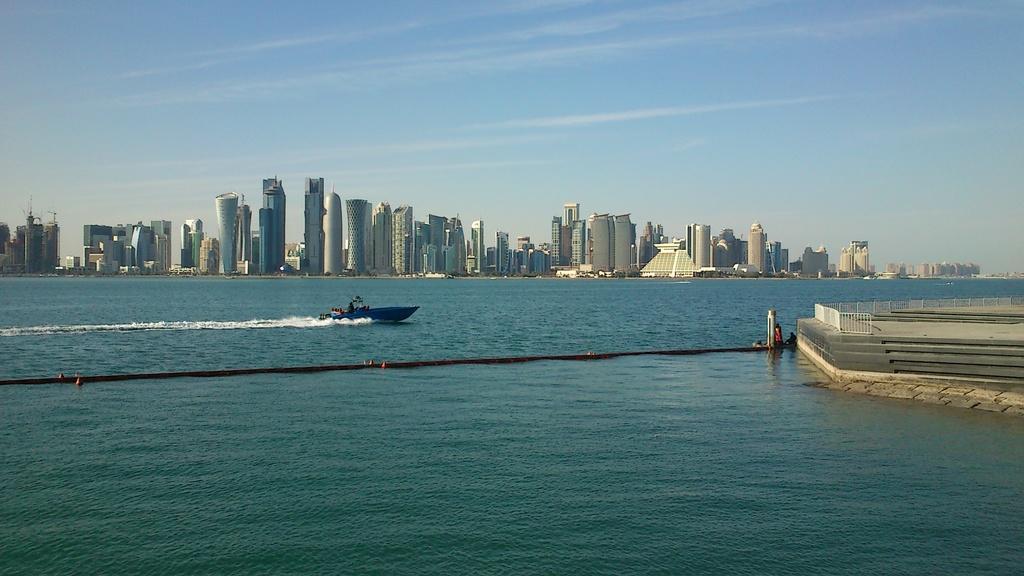How would you summarize this image in a sentence or two? In the picture there is a boat sailing on the water and on the right side there is a pavement, in the background there are many tall towers and buildings. 